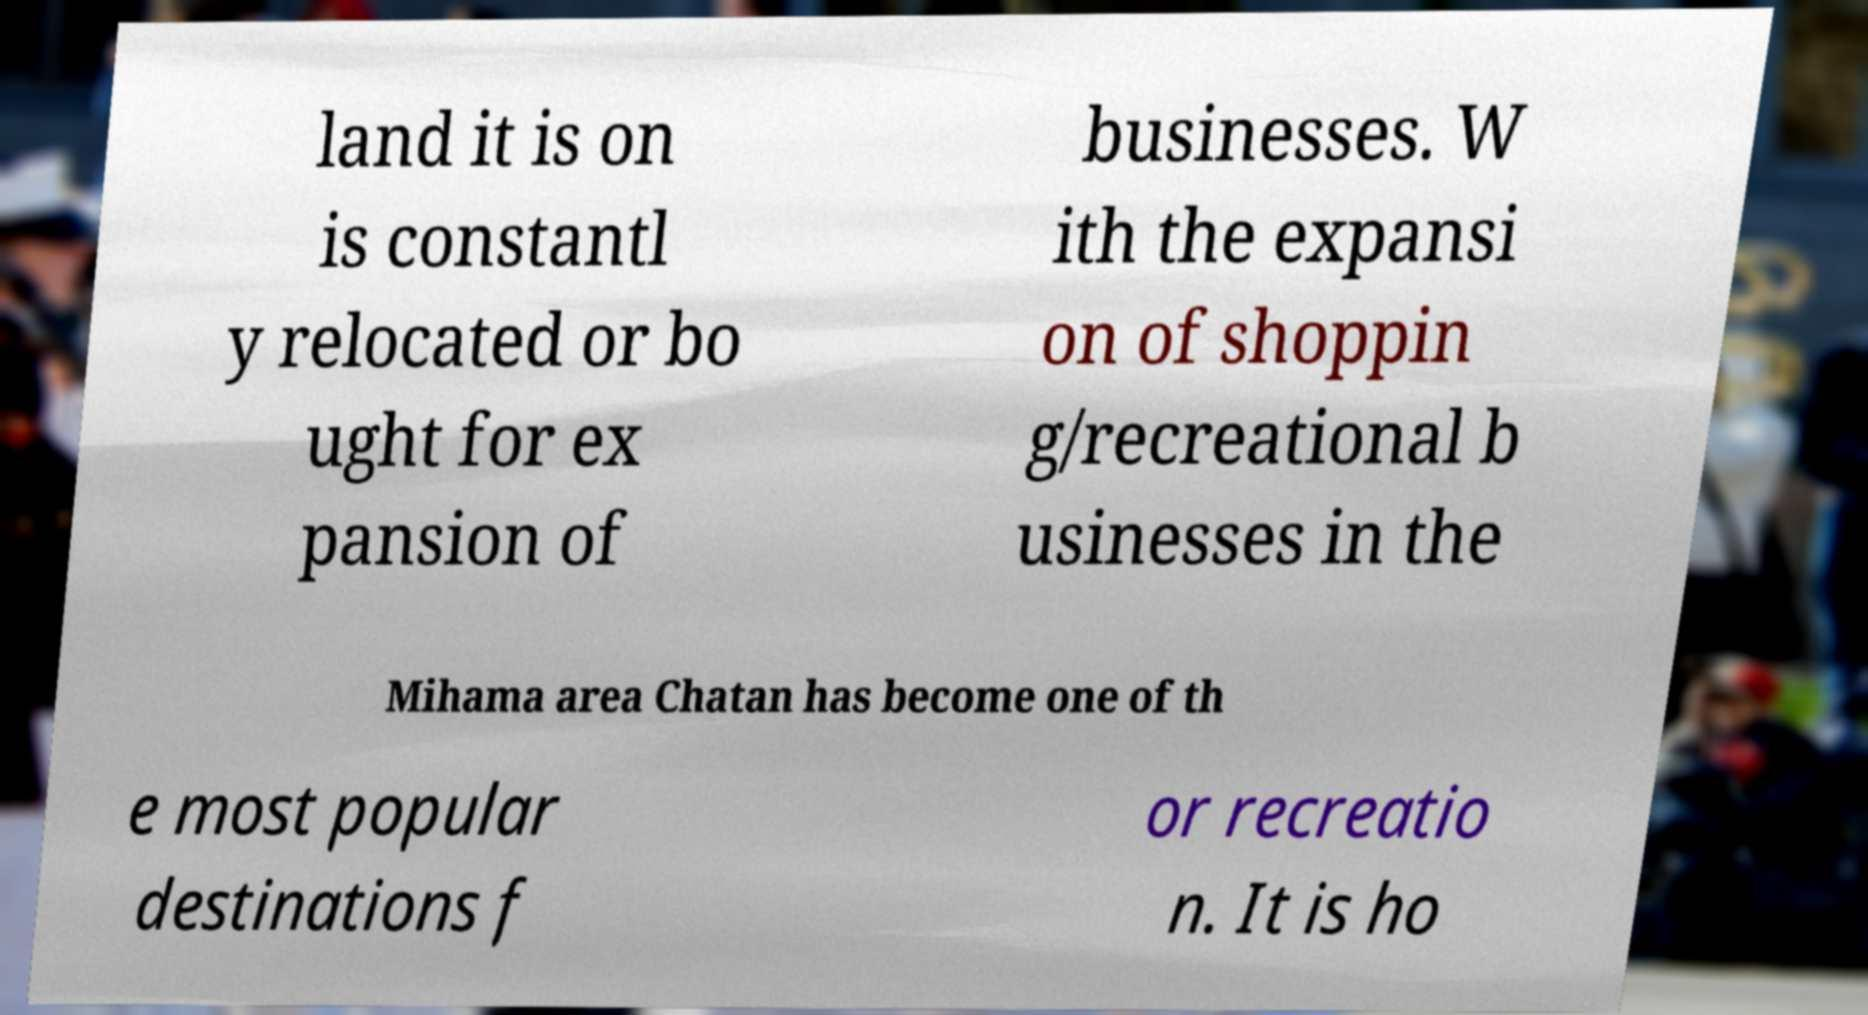Can you read and provide the text displayed in the image?This photo seems to have some interesting text. Can you extract and type it out for me? land it is on is constantl y relocated or bo ught for ex pansion of businesses. W ith the expansi on of shoppin g/recreational b usinesses in the Mihama area Chatan has become one of th e most popular destinations f or recreatio n. It is ho 